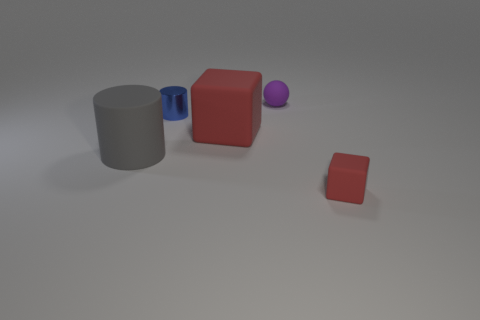Does the red block that is on the left side of the ball have the same material as the tiny cylinder?
Provide a succinct answer. No. There is a block left of the small red thing; what material is it?
Your response must be concise. Rubber. What is the size of the red matte thing behind the gray matte cylinder in front of the purple rubber thing?
Your answer should be compact. Large. Are there any other blocks that have the same material as the small cube?
Make the answer very short. Yes. There is a tiny object that is right of the rubber thing behind the small object left of the tiny purple matte object; what shape is it?
Provide a succinct answer. Cube. Do the matte block right of the purple rubber thing and the block that is to the left of the small purple thing have the same color?
Make the answer very short. Yes. There is a blue metal cylinder; are there any blue cylinders in front of it?
Give a very brief answer. No. How many small red shiny things are the same shape as the small red matte thing?
Offer a very short reply. 0. There is a small rubber object on the left side of the small matte object that is in front of the cylinder in front of the tiny blue metallic cylinder; what is its color?
Provide a short and direct response. Purple. Do the red thing that is behind the tiny red cube and the small object on the left side of the purple matte object have the same material?
Make the answer very short. No. 